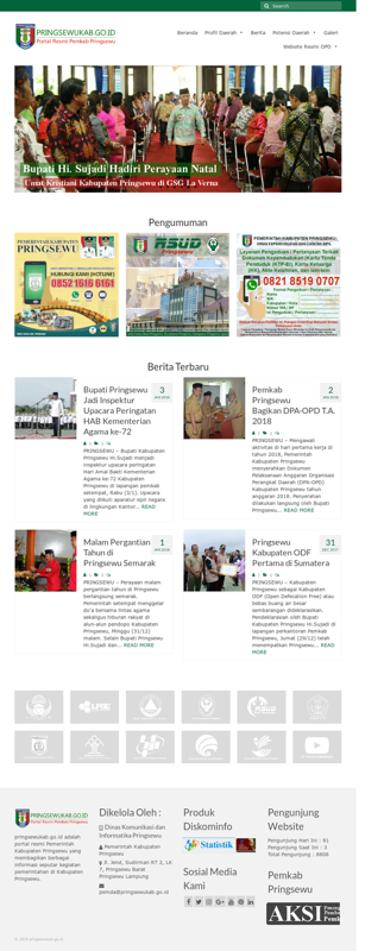What is the website mentioned in the image? The website mentioned in the image is NGSEWUKAB.GO.ID. What is one of the news headlines on the website? One of the news headlines is "Bupati Hi Sujadi Hadiri Perayaan Natal diGsG1aVerm." What is the contact number provided on the website? The contact number provided on the website is 0852 1616 6161 and 0821 3519 0707. 